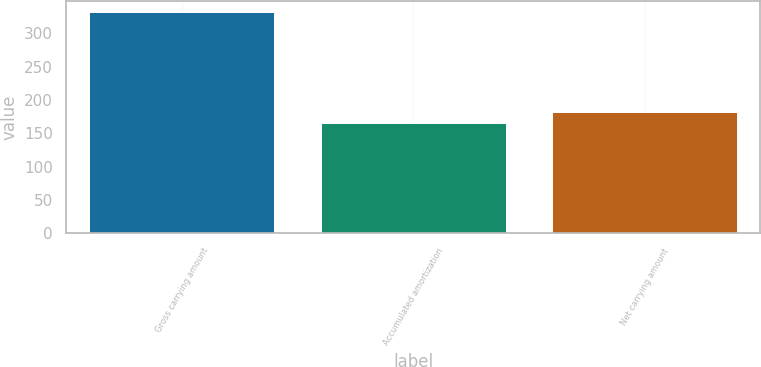Convert chart. <chart><loc_0><loc_0><loc_500><loc_500><bar_chart><fcel>Gross carrying amount<fcel>Accumulated amortization<fcel>Net carrying amount<nl><fcel>332<fcel>166<fcel>182.6<nl></chart> 